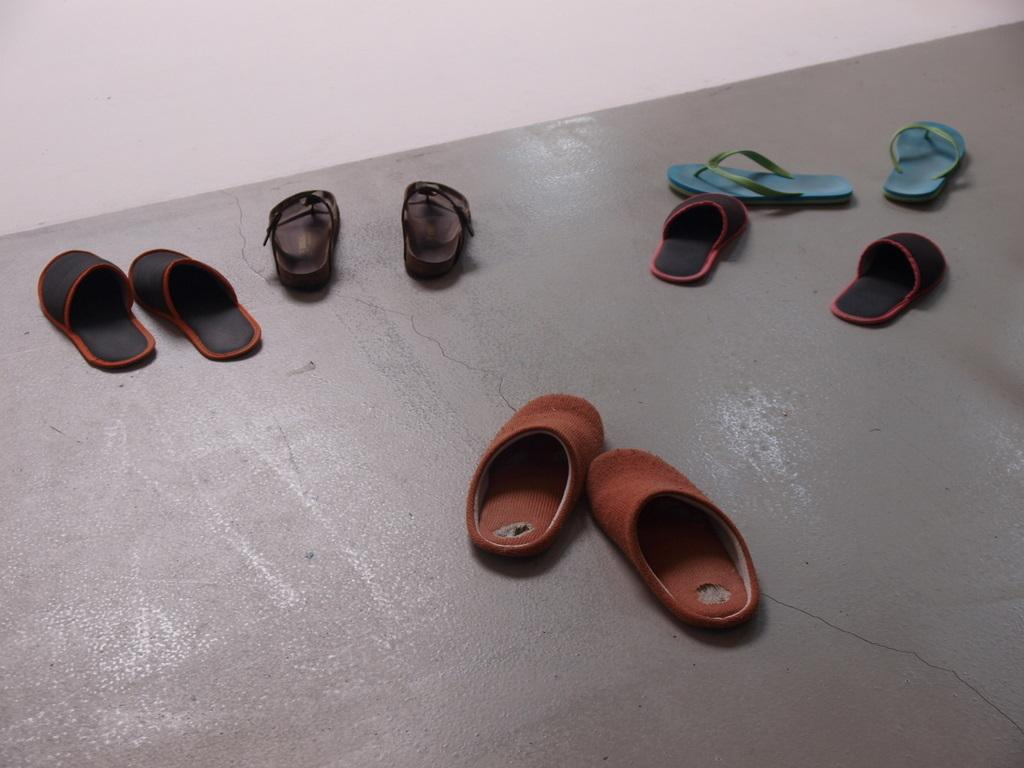What is at the bottom of the image? There is a floor at the bottom of the image. What can be seen on the floor? There are shoes on the floor. What is visible in the background of the image? There is a wall in the background of the image. What type of love is expressed by the shoes on the floor? There is no expression of love present in the image; it simply shows shoes on the floor. Are the shoes wearing stockings in the image? There is no mention of stockings in the image, only shoes on the floor. 